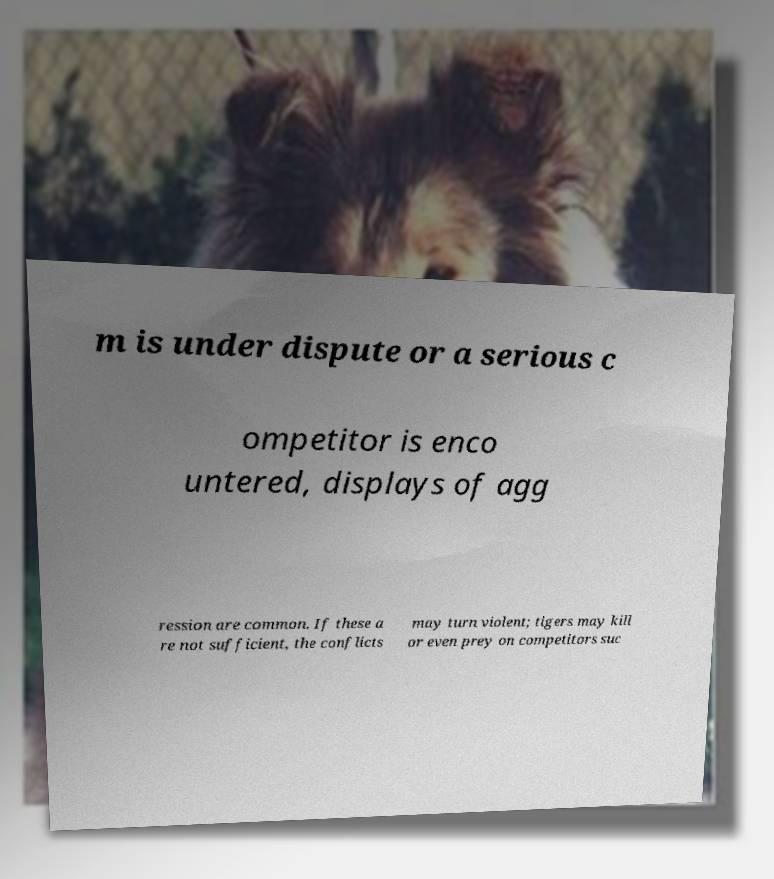Could you extract and type out the text from this image? m is under dispute or a serious c ompetitor is enco untered, displays of agg ression are common. If these a re not sufficient, the conflicts may turn violent; tigers may kill or even prey on competitors suc 